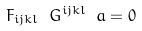<formula> <loc_0><loc_0><loc_500><loc_500>F _ { i j k l } \ G ^ { i j k l } \ a = 0</formula> 